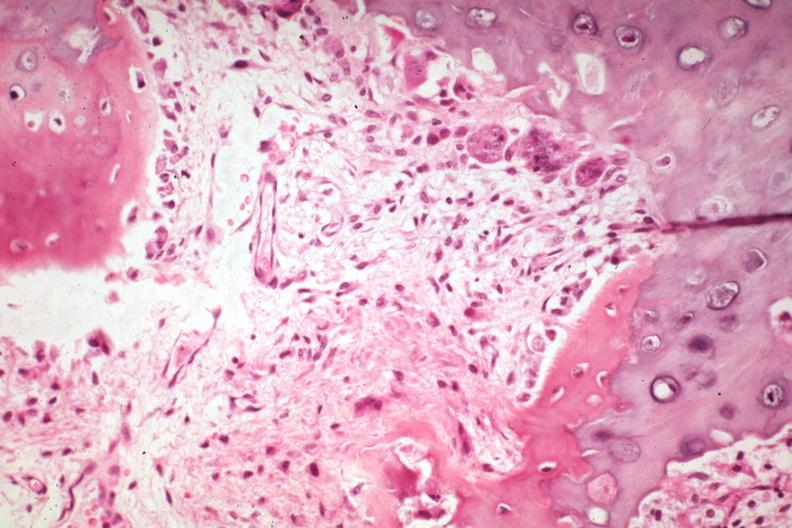what is present?
Answer the question using a single word or phrase. Joints 